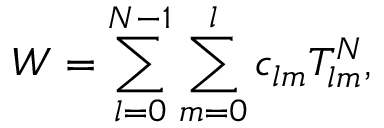<formula> <loc_0><loc_0><loc_500><loc_500>W = \sum _ { l = 0 } ^ { N - 1 } \sum _ { m = 0 } ^ { l } c _ { l m } T _ { l m } ^ { N } ,</formula> 